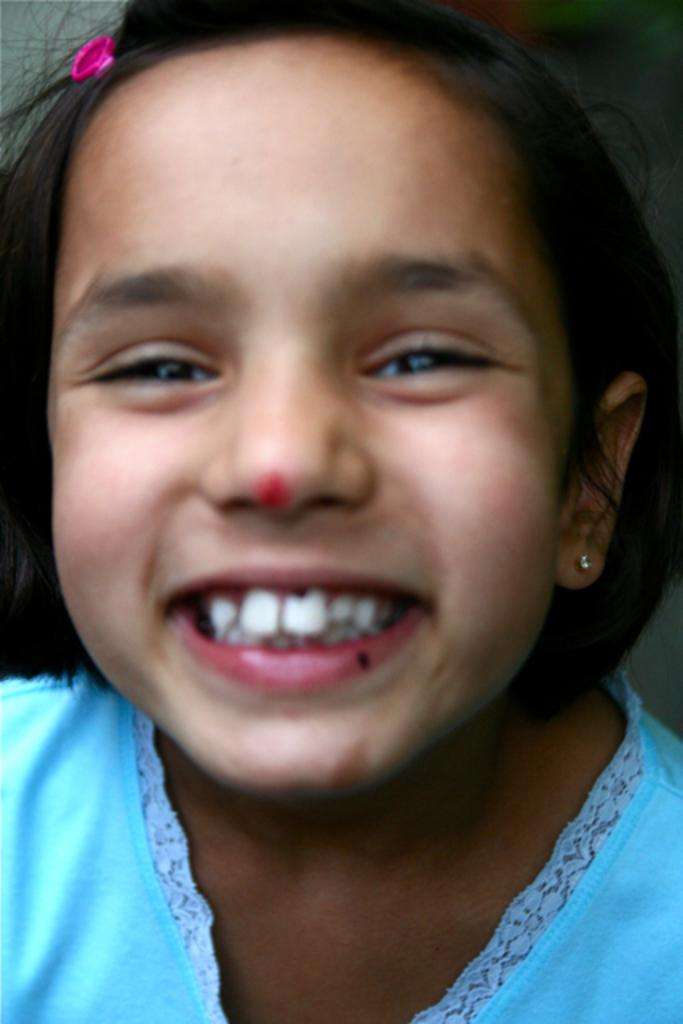Who is the main subject in the image? There is a little girl in the image. What is the girl doing in the image? The girl is smiling. What type of stove is visible in the image? There is no stove present in the image; it features a little girl who is smiling. What organization is responsible for the girl's smile in the image? There is no organization mentioned or implied in the image; it simply shows a little girl smiling. 